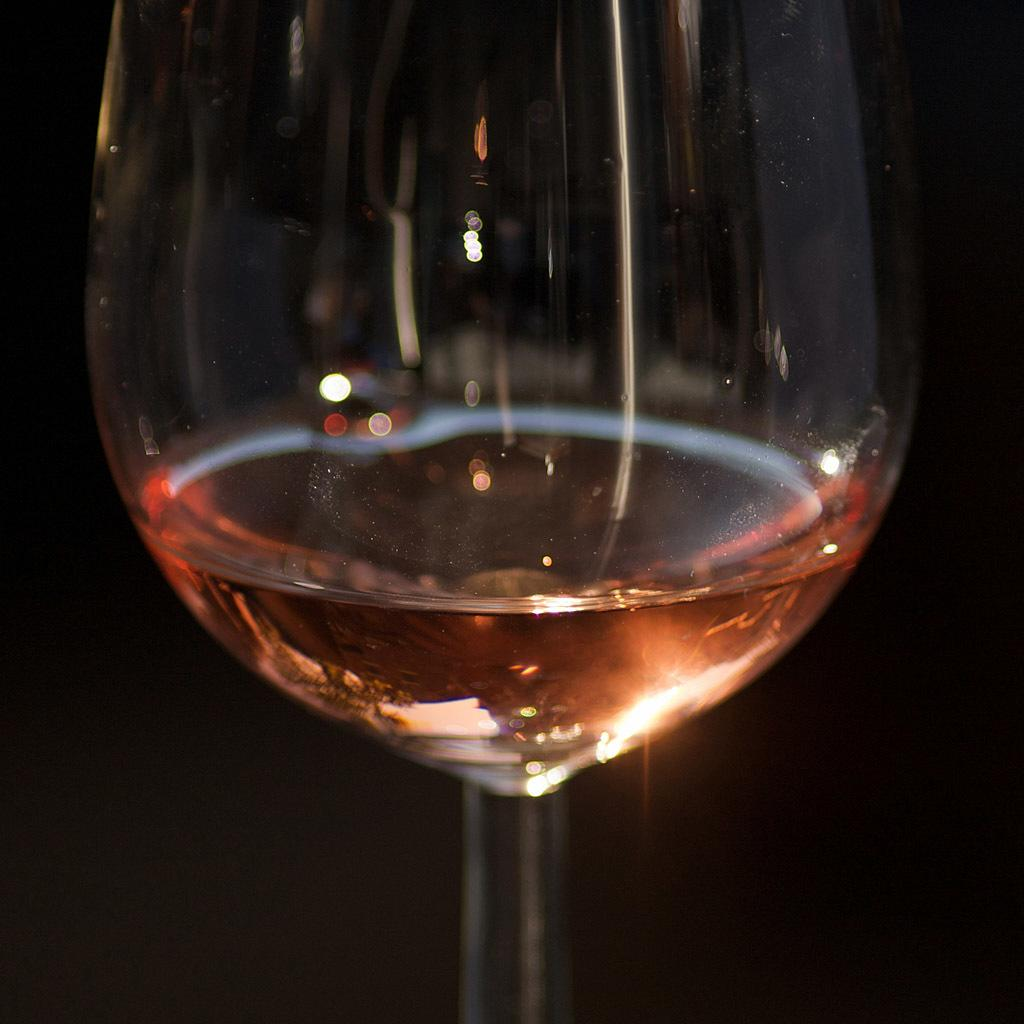What object is present in the image that can hold liquid? There is a glass in the image that can hold liquid. What is inside the glass? The glass contains some liquid. What type of noise can be heard coming from the glass in the image? There is no noise coming from the glass in the image. Who is the stranger holding the parcel in the image? There is no stranger or parcel present in the image; it only features a glass with some liquid. 